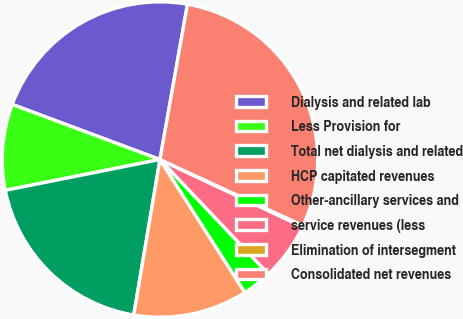Convert chart to OTSL. <chart><loc_0><loc_0><loc_500><loc_500><pie_chart><fcel>Dialysis and related lab<fcel>Less Provision for<fcel>Total net dialysis and related<fcel>HCP capitated revenues<fcel>Other-ancillary services and<fcel>service revenues (less<fcel>Elimination of intersegment<fcel>Consolidated net revenues<nl><fcel>22.11%<fcel>8.81%<fcel>19.21%<fcel>11.71%<fcel>3.02%<fcel>5.92%<fcel>0.12%<fcel>29.1%<nl></chart> 